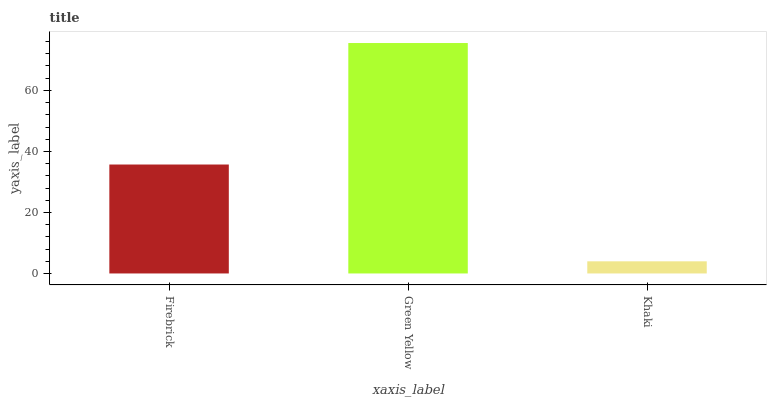Is Green Yellow the minimum?
Answer yes or no. No. Is Khaki the maximum?
Answer yes or no. No. Is Green Yellow greater than Khaki?
Answer yes or no. Yes. Is Khaki less than Green Yellow?
Answer yes or no. Yes. Is Khaki greater than Green Yellow?
Answer yes or no. No. Is Green Yellow less than Khaki?
Answer yes or no. No. Is Firebrick the high median?
Answer yes or no. Yes. Is Firebrick the low median?
Answer yes or no. Yes. Is Green Yellow the high median?
Answer yes or no. No. Is Khaki the low median?
Answer yes or no. No. 